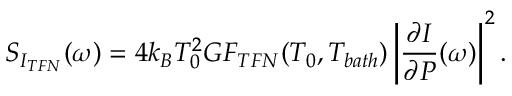<formula> <loc_0><loc_0><loc_500><loc_500>S _ { I _ { T F N } } ( \omega ) = 4 k _ { B } T _ { 0 } ^ { 2 } G F _ { T F N } ( T _ { 0 } , T _ { b a t h } ) \left | \frac { \partial I } { \partial P } ( \omega ) \right | ^ { 2 } .</formula> 